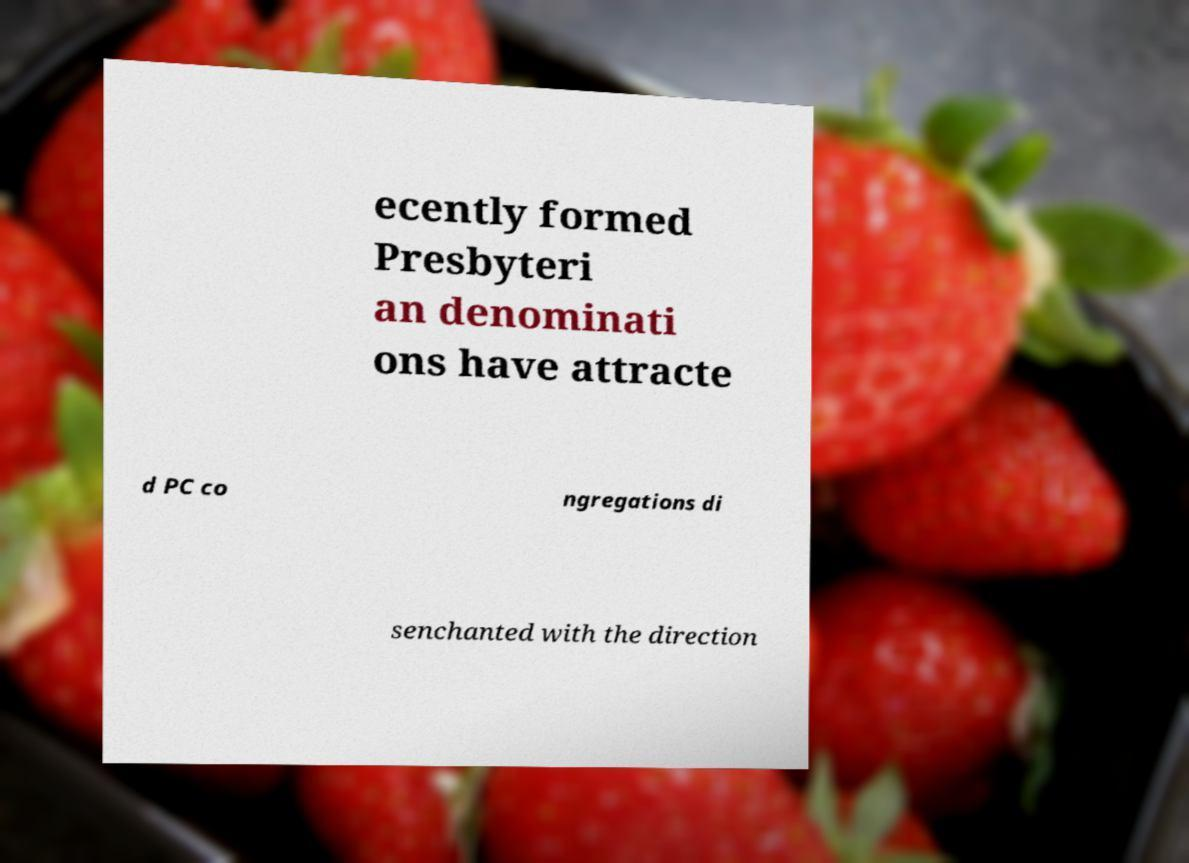Can you read and provide the text displayed in the image?This photo seems to have some interesting text. Can you extract and type it out for me? ecently formed Presbyteri an denominati ons have attracte d PC co ngregations di senchanted with the direction 